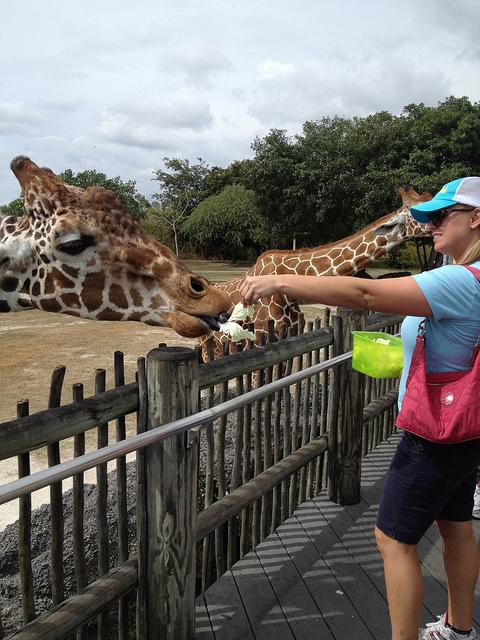Is the woman scared of giraffes?
Write a very short answer. No. How many animals?
Keep it brief. 2. What color is the woman's purse?
Answer briefly. Pink. 